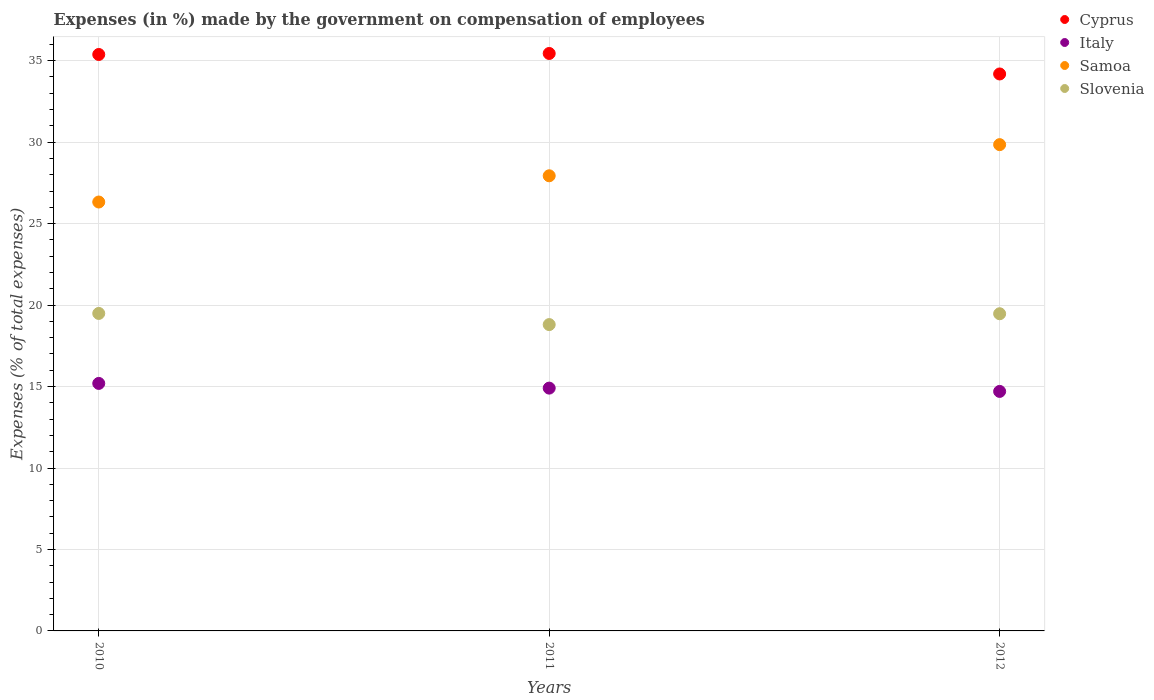Is the number of dotlines equal to the number of legend labels?
Offer a very short reply. Yes. What is the percentage of expenses made by the government on compensation of employees in Cyprus in 2010?
Your response must be concise. 35.38. Across all years, what is the maximum percentage of expenses made by the government on compensation of employees in Slovenia?
Give a very brief answer. 19.49. Across all years, what is the minimum percentage of expenses made by the government on compensation of employees in Italy?
Offer a terse response. 14.7. What is the total percentage of expenses made by the government on compensation of employees in Italy in the graph?
Provide a short and direct response. 44.8. What is the difference between the percentage of expenses made by the government on compensation of employees in Italy in 2010 and that in 2012?
Provide a succinct answer. 0.49. What is the difference between the percentage of expenses made by the government on compensation of employees in Cyprus in 2010 and the percentage of expenses made by the government on compensation of employees in Slovenia in 2012?
Make the answer very short. 15.91. What is the average percentage of expenses made by the government on compensation of employees in Cyprus per year?
Give a very brief answer. 35. In the year 2011, what is the difference between the percentage of expenses made by the government on compensation of employees in Slovenia and percentage of expenses made by the government on compensation of employees in Italy?
Make the answer very short. 3.9. What is the ratio of the percentage of expenses made by the government on compensation of employees in Italy in 2010 to that in 2012?
Ensure brevity in your answer.  1.03. Is the percentage of expenses made by the government on compensation of employees in Samoa in 2010 less than that in 2012?
Offer a terse response. Yes. Is the difference between the percentage of expenses made by the government on compensation of employees in Slovenia in 2010 and 2012 greater than the difference between the percentage of expenses made by the government on compensation of employees in Italy in 2010 and 2012?
Your answer should be very brief. No. What is the difference between the highest and the second highest percentage of expenses made by the government on compensation of employees in Cyprus?
Provide a short and direct response. 0.06. What is the difference between the highest and the lowest percentage of expenses made by the government on compensation of employees in Cyprus?
Give a very brief answer. 1.26. Is the sum of the percentage of expenses made by the government on compensation of employees in Italy in 2011 and 2012 greater than the maximum percentage of expenses made by the government on compensation of employees in Samoa across all years?
Give a very brief answer. No. Is it the case that in every year, the sum of the percentage of expenses made by the government on compensation of employees in Cyprus and percentage of expenses made by the government on compensation of employees in Samoa  is greater than the sum of percentage of expenses made by the government on compensation of employees in Slovenia and percentage of expenses made by the government on compensation of employees in Italy?
Your answer should be compact. Yes. Does the percentage of expenses made by the government on compensation of employees in Cyprus monotonically increase over the years?
Ensure brevity in your answer.  No. Is the percentage of expenses made by the government on compensation of employees in Italy strictly less than the percentage of expenses made by the government on compensation of employees in Cyprus over the years?
Provide a short and direct response. Yes. Does the graph contain any zero values?
Keep it short and to the point. No. How many legend labels are there?
Provide a short and direct response. 4. How are the legend labels stacked?
Make the answer very short. Vertical. What is the title of the graph?
Your answer should be compact. Expenses (in %) made by the government on compensation of employees. What is the label or title of the Y-axis?
Make the answer very short. Expenses (% of total expenses). What is the Expenses (% of total expenses) in Cyprus in 2010?
Offer a very short reply. 35.38. What is the Expenses (% of total expenses) of Italy in 2010?
Provide a short and direct response. 15.19. What is the Expenses (% of total expenses) in Samoa in 2010?
Your answer should be very brief. 26.33. What is the Expenses (% of total expenses) of Slovenia in 2010?
Your answer should be very brief. 19.49. What is the Expenses (% of total expenses) of Cyprus in 2011?
Provide a succinct answer. 35.44. What is the Expenses (% of total expenses) of Italy in 2011?
Give a very brief answer. 14.9. What is the Expenses (% of total expenses) of Samoa in 2011?
Your answer should be compact. 27.94. What is the Expenses (% of total expenses) of Slovenia in 2011?
Your response must be concise. 18.8. What is the Expenses (% of total expenses) in Cyprus in 2012?
Your answer should be compact. 34.19. What is the Expenses (% of total expenses) in Italy in 2012?
Your answer should be very brief. 14.7. What is the Expenses (% of total expenses) of Samoa in 2012?
Offer a very short reply. 29.85. What is the Expenses (% of total expenses) in Slovenia in 2012?
Provide a short and direct response. 19.47. Across all years, what is the maximum Expenses (% of total expenses) of Cyprus?
Provide a short and direct response. 35.44. Across all years, what is the maximum Expenses (% of total expenses) in Italy?
Offer a very short reply. 15.19. Across all years, what is the maximum Expenses (% of total expenses) of Samoa?
Your answer should be very brief. 29.85. Across all years, what is the maximum Expenses (% of total expenses) of Slovenia?
Give a very brief answer. 19.49. Across all years, what is the minimum Expenses (% of total expenses) of Cyprus?
Provide a short and direct response. 34.19. Across all years, what is the minimum Expenses (% of total expenses) of Italy?
Provide a succinct answer. 14.7. Across all years, what is the minimum Expenses (% of total expenses) of Samoa?
Offer a terse response. 26.33. Across all years, what is the minimum Expenses (% of total expenses) of Slovenia?
Give a very brief answer. 18.8. What is the total Expenses (% of total expenses) of Cyprus in the graph?
Your answer should be very brief. 105.01. What is the total Expenses (% of total expenses) in Italy in the graph?
Give a very brief answer. 44.8. What is the total Expenses (% of total expenses) of Samoa in the graph?
Your response must be concise. 84.11. What is the total Expenses (% of total expenses) of Slovenia in the graph?
Provide a succinct answer. 57.76. What is the difference between the Expenses (% of total expenses) in Cyprus in 2010 and that in 2011?
Provide a short and direct response. -0.06. What is the difference between the Expenses (% of total expenses) of Italy in 2010 and that in 2011?
Offer a terse response. 0.29. What is the difference between the Expenses (% of total expenses) of Samoa in 2010 and that in 2011?
Keep it short and to the point. -1.61. What is the difference between the Expenses (% of total expenses) in Slovenia in 2010 and that in 2011?
Provide a short and direct response. 0.68. What is the difference between the Expenses (% of total expenses) in Cyprus in 2010 and that in 2012?
Provide a succinct answer. 1.2. What is the difference between the Expenses (% of total expenses) in Italy in 2010 and that in 2012?
Keep it short and to the point. 0.49. What is the difference between the Expenses (% of total expenses) in Samoa in 2010 and that in 2012?
Keep it short and to the point. -3.52. What is the difference between the Expenses (% of total expenses) in Slovenia in 2010 and that in 2012?
Offer a very short reply. 0.02. What is the difference between the Expenses (% of total expenses) in Cyprus in 2011 and that in 2012?
Your answer should be compact. 1.26. What is the difference between the Expenses (% of total expenses) of Italy in 2011 and that in 2012?
Your answer should be very brief. 0.2. What is the difference between the Expenses (% of total expenses) in Samoa in 2011 and that in 2012?
Give a very brief answer. -1.91. What is the difference between the Expenses (% of total expenses) of Slovenia in 2011 and that in 2012?
Make the answer very short. -0.67. What is the difference between the Expenses (% of total expenses) of Cyprus in 2010 and the Expenses (% of total expenses) of Italy in 2011?
Make the answer very short. 20.48. What is the difference between the Expenses (% of total expenses) of Cyprus in 2010 and the Expenses (% of total expenses) of Samoa in 2011?
Your answer should be compact. 7.45. What is the difference between the Expenses (% of total expenses) in Cyprus in 2010 and the Expenses (% of total expenses) in Slovenia in 2011?
Your answer should be very brief. 16.58. What is the difference between the Expenses (% of total expenses) in Italy in 2010 and the Expenses (% of total expenses) in Samoa in 2011?
Your answer should be compact. -12.74. What is the difference between the Expenses (% of total expenses) in Italy in 2010 and the Expenses (% of total expenses) in Slovenia in 2011?
Provide a succinct answer. -3.61. What is the difference between the Expenses (% of total expenses) in Samoa in 2010 and the Expenses (% of total expenses) in Slovenia in 2011?
Your answer should be compact. 7.52. What is the difference between the Expenses (% of total expenses) in Cyprus in 2010 and the Expenses (% of total expenses) in Italy in 2012?
Provide a succinct answer. 20.68. What is the difference between the Expenses (% of total expenses) of Cyprus in 2010 and the Expenses (% of total expenses) of Samoa in 2012?
Your answer should be compact. 5.53. What is the difference between the Expenses (% of total expenses) in Cyprus in 2010 and the Expenses (% of total expenses) in Slovenia in 2012?
Your response must be concise. 15.91. What is the difference between the Expenses (% of total expenses) in Italy in 2010 and the Expenses (% of total expenses) in Samoa in 2012?
Provide a succinct answer. -14.66. What is the difference between the Expenses (% of total expenses) of Italy in 2010 and the Expenses (% of total expenses) of Slovenia in 2012?
Offer a very short reply. -4.28. What is the difference between the Expenses (% of total expenses) in Samoa in 2010 and the Expenses (% of total expenses) in Slovenia in 2012?
Your answer should be very brief. 6.86. What is the difference between the Expenses (% of total expenses) in Cyprus in 2011 and the Expenses (% of total expenses) in Italy in 2012?
Make the answer very short. 20.74. What is the difference between the Expenses (% of total expenses) of Cyprus in 2011 and the Expenses (% of total expenses) of Samoa in 2012?
Offer a very short reply. 5.6. What is the difference between the Expenses (% of total expenses) of Cyprus in 2011 and the Expenses (% of total expenses) of Slovenia in 2012?
Your answer should be compact. 15.98. What is the difference between the Expenses (% of total expenses) in Italy in 2011 and the Expenses (% of total expenses) in Samoa in 2012?
Ensure brevity in your answer.  -14.94. What is the difference between the Expenses (% of total expenses) in Italy in 2011 and the Expenses (% of total expenses) in Slovenia in 2012?
Your answer should be compact. -4.57. What is the difference between the Expenses (% of total expenses) in Samoa in 2011 and the Expenses (% of total expenses) in Slovenia in 2012?
Keep it short and to the point. 8.47. What is the average Expenses (% of total expenses) of Cyprus per year?
Provide a succinct answer. 35. What is the average Expenses (% of total expenses) of Italy per year?
Keep it short and to the point. 14.93. What is the average Expenses (% of total expenses) in Samoa per year?
Keep it short and to the point. 28.04. What is the average Expenses (% of total expenses) in Slovenia per year?
Your answer should be very brief. 19.25. In the year 2010, what is the difference between the Expenses (% of total expenses) in Cyprus and Expenses (% of total expenses) in Italy?
Your answer should be compact. 20.19. In the year 2010, what is the difference between the Expenses (% of total expenses) of Cyprus and Expenses (% of total expenses) of Samoa?
Offer a terse response. 9.06. In the year 2010, what is the difference between the Expenses (% of total expenses) of Cyprus and Expenses (% of total expenses) of Slovenia?
Provide a short and direct response. 15.89. In the year 2010, what is the difference between the Expenses (% of total expenses) in Italy and Expenses (% of total expenses) in Samoa?
Keep it short and to the point. -11.13. In the year 2010, what is the difference between the Expenses (% of total expenses) of Italy and Expenses (% of total expenses) of Slovenia?
Your answer should be compact. -4.3. In the year 2010, what is the difference between the Expenses (% of total expenses) in Samoa and Expenses (% of total expenses) in Slovenia?
Keep it short and to the point. 6.84. In the year 2011, what is the difference between the Expenses (% of total expenses) of Cyprus and Expenses (% of total expenses) of Italy?
Make the answer very short. 20.54. In the year 2011, what is the difference between the Expenses (% of total expenses) in Cyprus and Expenses (% of total expenses) in Samoa?
Your answer should be compact. 7.51. In the year 2011, what is the difference between the Expenses (% of total expenses) of Cyprus and Expenses (% of total expenses) of Slovenia?
Your answer should be very brief. 16.64. In the year 2011, what is the difference between the Expenses (% of total expenses) of Italy and Expenses (% of total expenses) of Samoa?
Ensure brevity in your answer.  -13.03. In the year 2011, what is the difference between the Expenses (% of total expenses) in Italy and Expenses (% of total expenses) in Slovenia?
Your answer should be compact. -3.9. In the year 2011, what is the difference between the Expenses (% of total expenses) of Samoa and Expenses (% of total expenses) of Slovenia?
Your response must be concise. 9.13. In the year 2012, what is the difference between the Expenses (% of total expenses) in Cyprus and Expenses (% of total expenses) in Italy?
Provide a succinct answer. 19.48. In the year 2012, what is the difference between the Expenses (% of total expenses) in Cyprus and Expenses (% of total expenses) in Samoa?
Ensure brevity in your answer.  4.34. In the year 2012, what is the difference between the Expenses (% of total expenses) of Cyprus and Expenses (% of total expenses) of Slovenia?
Provide a succinct answer. 14.72. In the year 2012, what is the difference between the Expenses (% of total expenses) of Italy and Expenses (% of total expenses) of Samoa?
Ensure brevity in your answer.  -15.15. In the year 2012, what is the difference between the Expenses (% of total expenses) in Italy and Expenses (% of total expenses) in Slovenia?
Ensure brevity in your answer.  -4.77. In the year 2012, what is the difference between the Expenses (% of total expenses) in Samoa and Expenses (% of total expenses) in Slovenia?
Offer a very short reply. 10.38. What is the ratio of the Expenses (% of total expenses) of Italy in 2010 to that in 2011?
Give a very brief answer. 1.02. What is the ratio of the Expenses (% of total expenses) of Samoa in 2010 to that in 2011?
Provide a short and direct response. 0.94. What is the ratio of the Expenses (% of total expenses) in Slovenia in 2010 to that in 2011?
Make the answer very short. 1.04. What is the ratio of the Expenses (% of total expenses) of Cyprus in 2010 to that in 2012?
Give a very brief answer. 1.03. What is the ratio of the Expenses (% of total expenses) in Italy in 2010 to that in 2012?
Ensure brevity in your answer.  1.03. What is the ratio of the Expenses (% of total expenses) of Samoa in 2010 to that in 2012?
Your answer should be compact. 0.88. What is the ratio of the Expenses (% of total expenses) of Slovenia in 2010 to that in 2012?
Your response must be concise. 1. What is the ratio of the Expenses (% of total expenses) of Cyprus in 2011 to that in 2012?
Provide a succinct answer. 1.04. What is the ratio of the Expenses (% of total expenses) of Italy in 2011 to that in 2012?
Give a very brief answer. 1.01. What is the ratio of the Expenses (% of total expenses) in Samoa in 2011 to that in 2012?
Your answer should be compact. 0.94. What is the ratio of the Expenses (% of total expenses) of Slovenia in 2011 to that in 2012?
Provide a short and direct response. 0.97. What is the difference between the highest and the second highest Expenses (% of total expenses) of Cyprus?
Provide a succinct answer. 0.06. What is the difference between the highest and the second highest Expenses (% of total expenses) in Italy?
Make the answer very short. 0.29. What is the difference between the highest and the second highest Expenses (% of total expenses) in Samoa?
Offer a very short reply. 1.91. What is the difference between the highest and the second highest Expenses (% of total expenses) of Slovenia?
Provide a short and direct response. 0.02. What is the difference between the highest and the lowest Expenses (% of total expenses) in Cyprus?
Your answer should be compact. 1.26. What is the difference between the highest and the lowest Expenses (% of total expenses) in Italy?
Your answer should be very brief. 0.49. What is the difference between the highest and the lowest Expenses (% of total expenses) of Samoa?
Your answer should be compact. 3.52. What is the difference between the highest and the lowest Expenses (% of total expenses) of Slovenia?
Offer a very short reply. 0.68. 